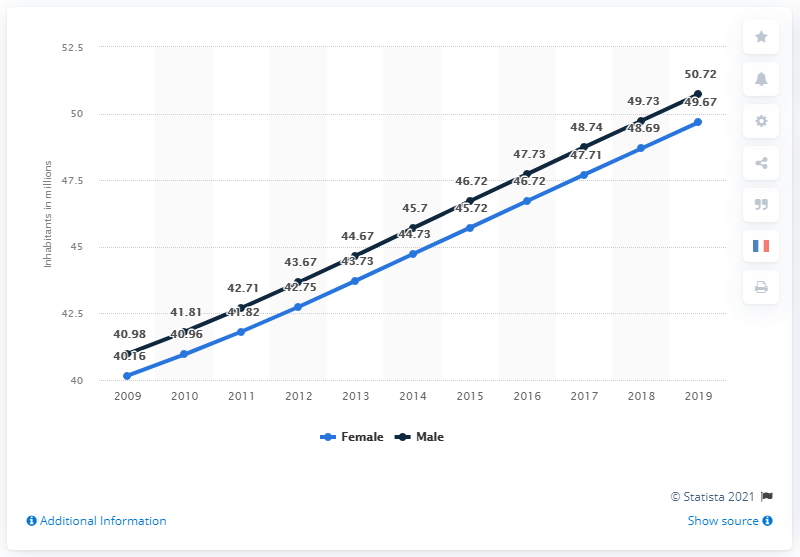Mention a couple of crucial points in this snapshot. According to data from 2019, the male population in Egypt was approximately 50.72 million. In 2019, Egypt's female population was approximately 49.67 million. 